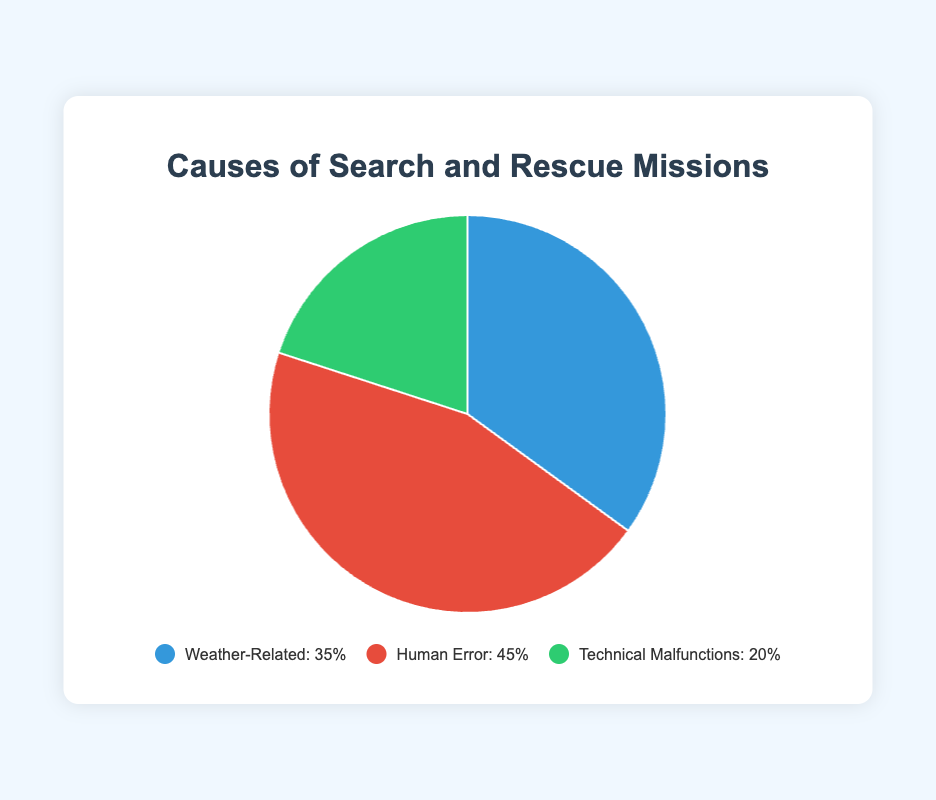How many more search and rescue missions are caused by human error compared to technical malfunctions? The percentage of missions caused by human error is 45%, and the percentage caused by technical malfunctions is 20%. Subtract 20% from 45%.
Answer: 25% Are weather-related causes responsible for more or fewer missions than technical malfunctions? The percentage of missions caused by weather-related issues is 35%, while technical malfunctions account for 20%. Compare the two values.
Answer: More Which cause is represented by the largest section of the pie chart, and what is its percentage? Look at the pie chart and identify the largest section. The percentage for this section is also labeled in the legend.
Answer: Human Error, 45% What is the combined percentage of search and rescue missions caused by weather-related and technical malfunctions? Add the percentage of missions caused by weather-related issues (35%) and technical malfunctions (20%).
Answer: 55% If the city wants to reduce the number of search and rescue missions, which cause should be prioritized based on the chart? Identify the cause with the highest percentage in the chart. This cause contributes the most to the total number of missions.
Answer: Human Error Which cause has the smallest section in the pie chart, and what is its percentage? Look at the pie chart and identify the smallest section. The percentage for this section is also labeled in the legend.
Answer: Technical Malfunctions, 20% Compare the size of the sections representing human error and weather-related issues. Which one is larger, and by how much? Human error accounts for 45%, whereas weather-related issues account for 35%. Subtract 35% from 45%.
Answer: Human Error is larger by 10% How does the use of color in the pie chart help differentiate the sections? The pie chart uses different colors: blue for weather-related, red for human error, and green for technical malfunctions. These distinct colors help visually separate the causes.
Answer: Uses distinct colors If the percentage of technical malfunctions increased by 5%, how would this change the overall distribution? The new percentage for technical malfunctions would be 25%. Recalculate the remaining percentages (weather-related and human error) while keeping the total sum as 100%.
Answer: Technical Malfunctions: 25%, Human Error: 45%, Weather-Related: 30% 